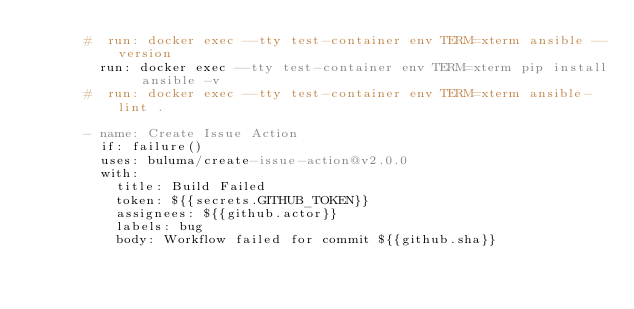Convert code to text. <code><loc_0><loc_0><loc_500><loc_500><_YAML_>      #  run: docker exec --tty test-container env TERM=xterm ansible --version
        run: docker exec --tty test-container env TERM=xterm pip install ansible -v
      #  run: docker exec --tty test-container env TERM=xterm ansible-lint .
          
      - name: Create Issue Action
        if: failure()
        uses: buluma/create-issue-action@v2.0.0
        with:
          title: Build Failed
          token: ${{secrets.GITHUB_TOKEN}}
          assignees: ${{github.actor}}
          labels: bug
          body: Workflow failed for commit ${{github.sha}}
</code> 